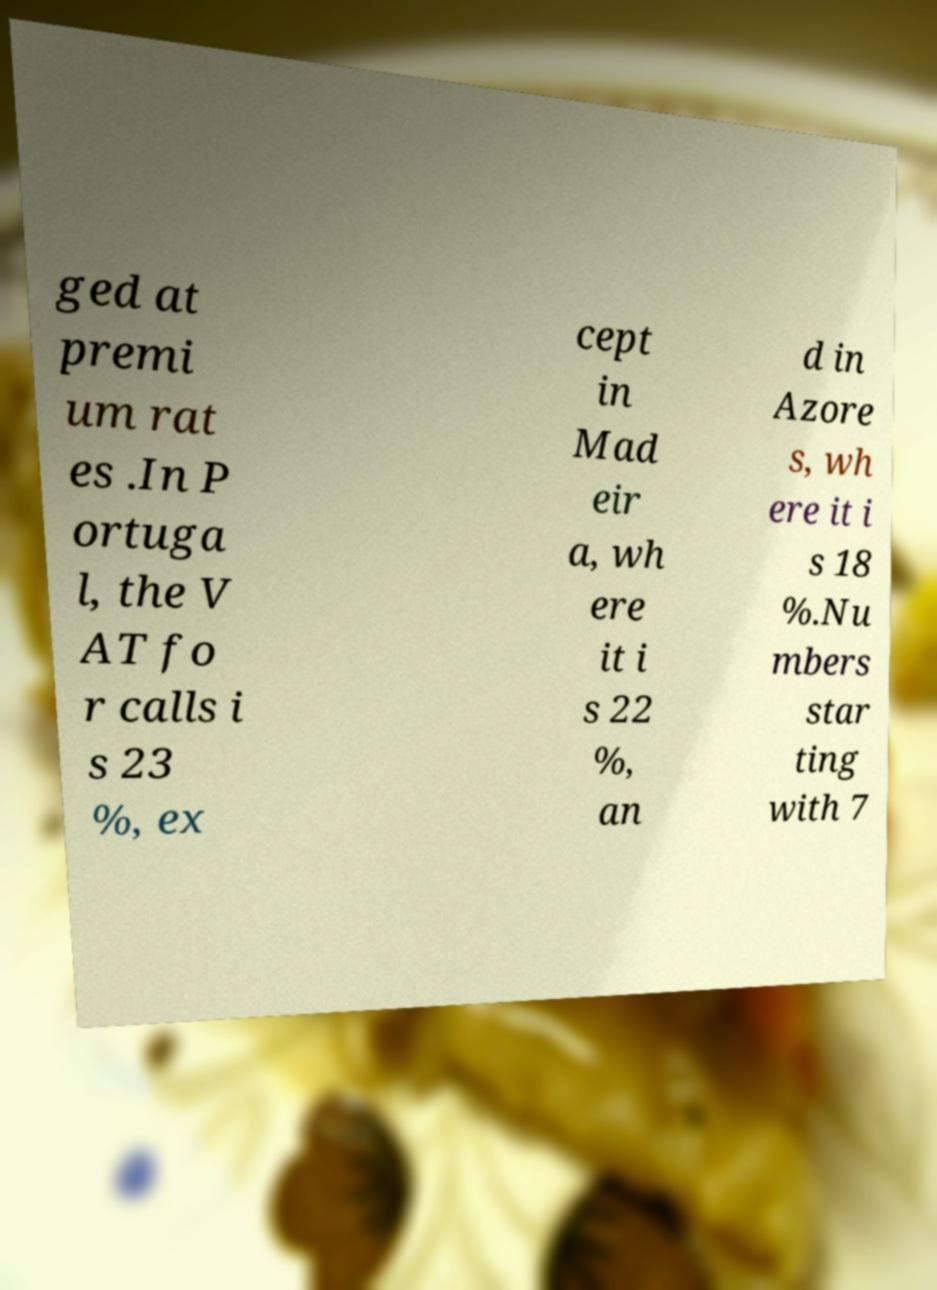Could you assist in decoding the text presented in this image and type it out clearly? ged at premi um rat es .In P ortuga l, the V AT fo r calls i s 23 %, ex cept in Mad eir a, wh ere it i s 22 %, an d in Azore s, wh ere it i s 18 %.Nu mbers star ting with 7 